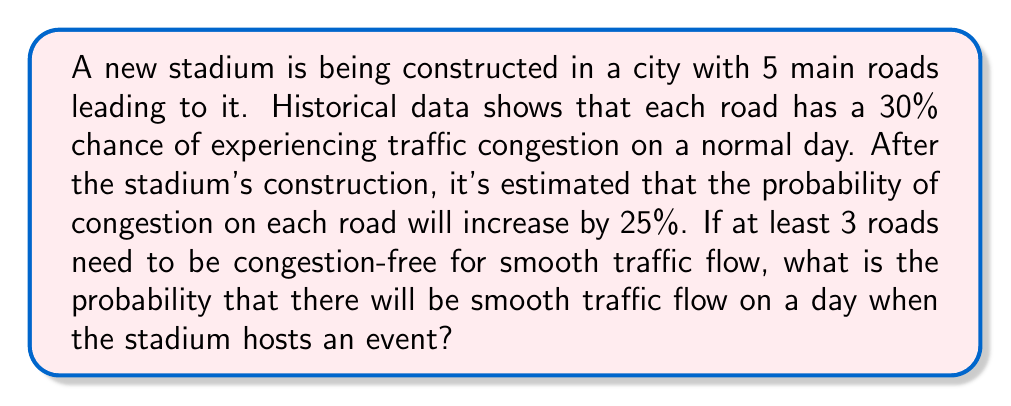Could you help me with this problem? Let's approach this step-by-step:

1) First, let's calculate the probability of congestion on each road after the stadium's construction:
   Original probability = 30% = 0.3
   Increase = 25% of 30% = 0.25 * 0.3 = 0.075
   New probability = 0.3 + 0.075 = 0.375 = 37.5%

2) So, the probability of each road being congestion-free is:
   $p(\text{congestion-free}) = 1 - 0.375 = 0.625 = 62.5\%$

3) We need at least 3 roads to be congestion-free out of 5 roads. This is a binomial probability problem.

4) The probability of exactly k successes in n trials is given by the formula:

   $$P(X = k) = \binom{n}{k} p^k (1-p)^{n-k}$$

   Where $n$ is the number of trials, $k$ is the number of successes, $p$ is the probability of success on each trial.

5) We need to calculate the probability of 3, 4, or 5 roads being congestion-free:

   $P(X \geq 3) = P(X = 3) + P(X = 4) + P(X = 5)$

6) Let's calculate each term:

   $P(X = 3) = \binom{5}{3} (0.625)^3 (0.375)^2 = 10 * 0.244140625 * 0.140625 = 0.343017578$

   $P(X = 4) = \binom{5}{4} (0.625)^4 (0.375)^1 = 5 * 0.152587891 * 0.375 = 0.286102295$

   $P(X = 5) = \binom{5}{5} (0.625)^5 (0.375)^0 = 1 * 0.095367432 * 1 = 0.095367432$

7) Sum these probabilities:

   $P(X \geq 3) = 0.343017578 + 0.286102295 + 0.095367432 = 0.724487305$

Therefore, the probability of smooth traffic flow (at least 3 roads congestion-free) is approximately 0.7245 or 72.45%.
Answer: 0.7245 